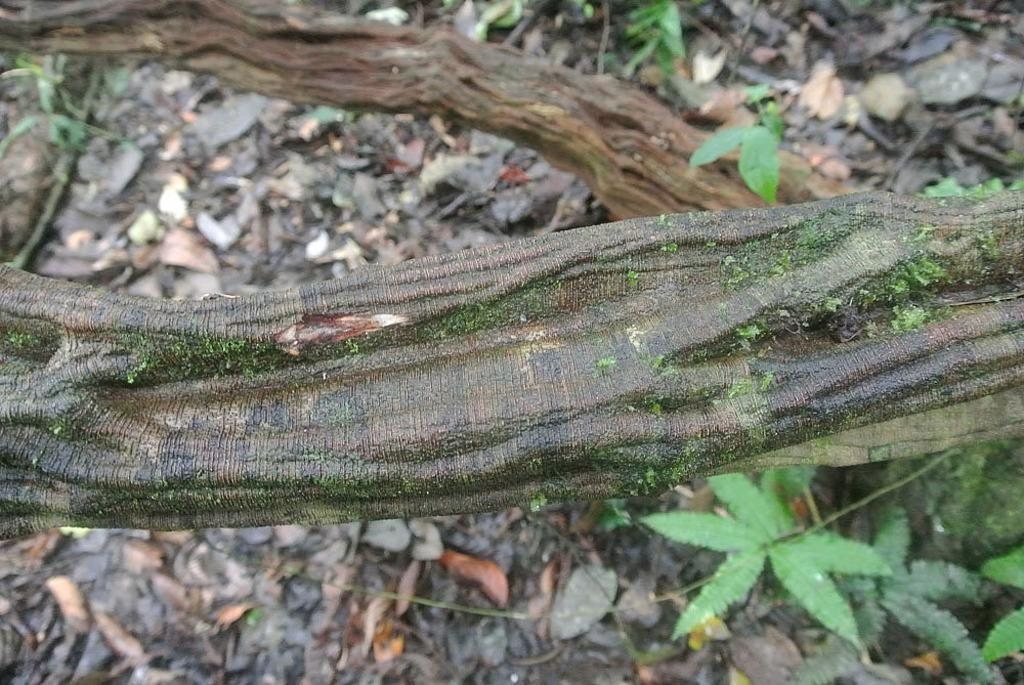What type of objects can be seen in the image? There are stems, plants, and leaves in the image. Can you describe the plants in the image? The plants in the image have stems and leaves. What part of the plants can be seen in the image? The stems and leaves of the plants are visible in the image. What type of notebook is being used to take notes about the airplane in the image? There is no airplane or notebook present in the image; it features plants with stems and leaves. 